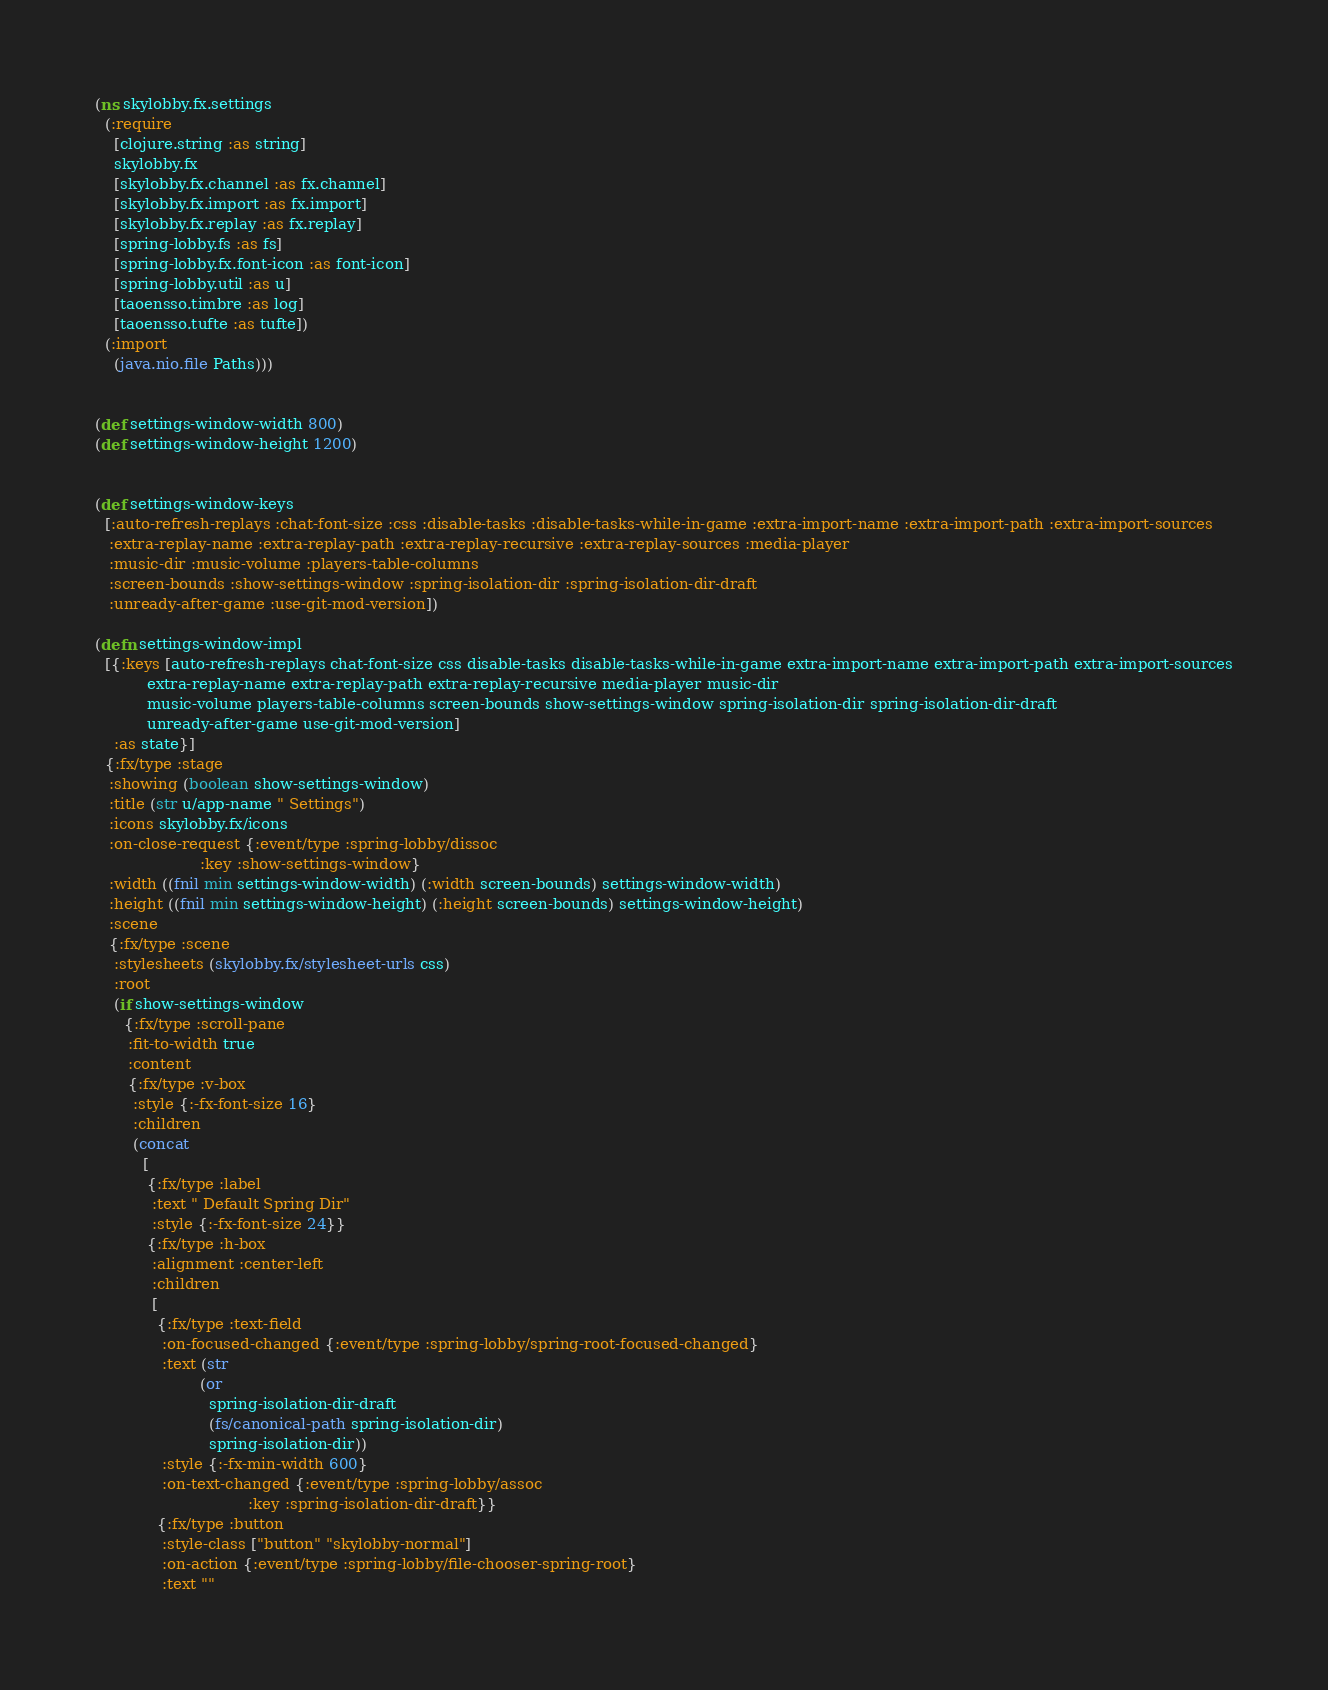<code> <loc_0><loc_0><loc_500><loc_500><_Clojure_>(ns skylobby.fx.settings
  (:require
    [clojure.string :as string]
    skylobby.fx
    [skylobby.fx.channel :as fx.channel]
    [skylobby.fx.import :as fx.import]
    [skylobby.fx.replay :as fx.replay]
    [spring-lobby.fs :as fs]
    [spring-lobby.fx.font-icon :as font-icon]
    [spring-lobby.util :as u]
    [taoensso.timbre :as log]
    [taoensso.tufte :as tufte])
  (:import
    (java.nio.file Paths)))


(def settings-window-width 800)
(def settings-window-height 1200)


(def settings-window-keys
  [:auto-refresh-replays :chat-font-size :css :disable-tasks :disable-tasks-while-in-game :extra-import-name :extra-import-path :extra-import-sources
   :extra-replay-name :extra-replay-path :extra-replay-recursive :extra-replay-sources :media-player
   :music-dir :music-volume :players-table-columns
   :screen-bounds :show-settings-window :spring-isolation-dir :spring-isolation-dir-draft
   :unready-after-game :use-git-mod-version])

(defn settings-window-impl
  [{:keys [auto-refresh-replays chat-font-size css disable-tasks disable-tasks-while-in-game extra-import-name extra-import-path extra-import-sources
           extra-replay-name extra-replay-path extra-replay-recursive media-player music-dir
           music-volume players-table-columns screen-bounds show-settings-window spring-isolation-dir spring-isolation-dir-draft
           unready-after-game use-git-mod-version]
    :as state}]
  {:fx/type :stage
   :showing (boolean show-settings-window)
   :title (str u/app-name " Settings")
   :icons skylobby.fx/icons
   :on-close-request {:event/type :spring-lobby/dissoc
                      :key :show-settings-window}
   :width ((fnil min settings-window-width) (:width screen-bounds) settings-window-width)
   :height ((fnil min settings-window-height) (:height screen-bounds) settings-window-height)
   :scene
   {:fx/type :scene
    :stylesheets (skylobby.fx/stylesheet-urls css)
    :root
    (if show-settings-window
      {:fx/type :scroll-pane
       :fit-to-width true
       :content
       {:fx/type :v-box
        :style {:-fx-font-size 16}
        :children
        (concat
          [
           {:fx/type :label
            :text " Default Spring Dir"
            :style {:-fx-font-size 24}}
           {:fx/type :h-box
            :alignment :center-left
            :children
            [
             {:fx/type :text-field
              :on-focused-changed {:event/type :spring-lobby/spring-root-focused-changed}
              :text (str
                      (or
                        spring-isolation-dir-draft
                        (fs/canonical-path spring-isolation-dir)
                        spring-isolation-dir))
              :style {:-fx-min-width 600}
              :on-text-changed {:event/type :spring-lobby/assoc
                                :key :spring-isolation-dir-draft}}
             {:fx/type :button
              :style-class ["button" "skylobby-normal"]
              :on-action {:event/type :spring-lobby/file-chooser-spring-root}
              :text ""</code> 